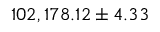<formula> <loc_0><loc_0><loc_500><loc_500>1 0 2 , 1 7 8 . 1 2 \pm 4 . 3 3</formula> 